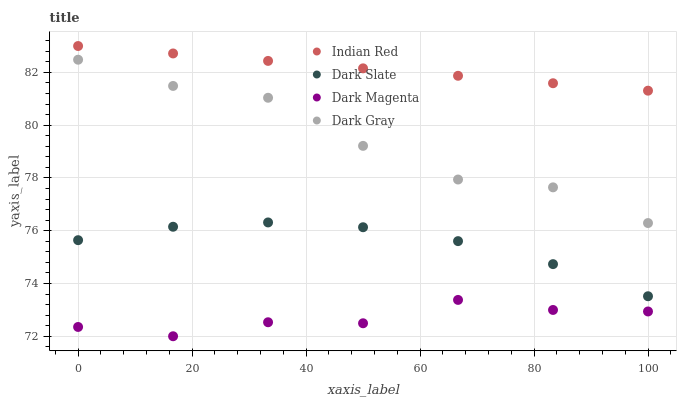Does Dark Magenta have the minimum area under the curve?
Answer yes or no. Yes. Does Indian Red have the maximum area under the curve?
Answer yes or no. Yes. Does Dark Slate have the minimum area under the curve?
Answer yes or no. No. Does Dark Slate have the maximum area under the curve?
Answer yes or no. No. Is Indian Red the smoothest?
Answer yes or no. Yes. Is Dark Gray the roughest?
Answer yes or no. Yes. Is Dark Slate the smoothest?
Answer yes or no. No. Is Dark Slate the roughest?
Answer yes or no. No. Does Dark Magenta have the lowest value?
Answer yes or no. Yes. Does Dark Slate have the lowest value?
Answer yes or no. No. Does Indian Red have the highest value?
Answer yes or no. Yes. Does Dark Slate have the highest value?
Answer yes or no. No. Is Dark Magenta less than Dark Slate?
Answer yes or no. Yes. Is Indian Red greater than Dark Magenta?
Answer yes or no. Yes. Does Dark Magenta intersect Dark Slate?
Answer yes or no. No. 